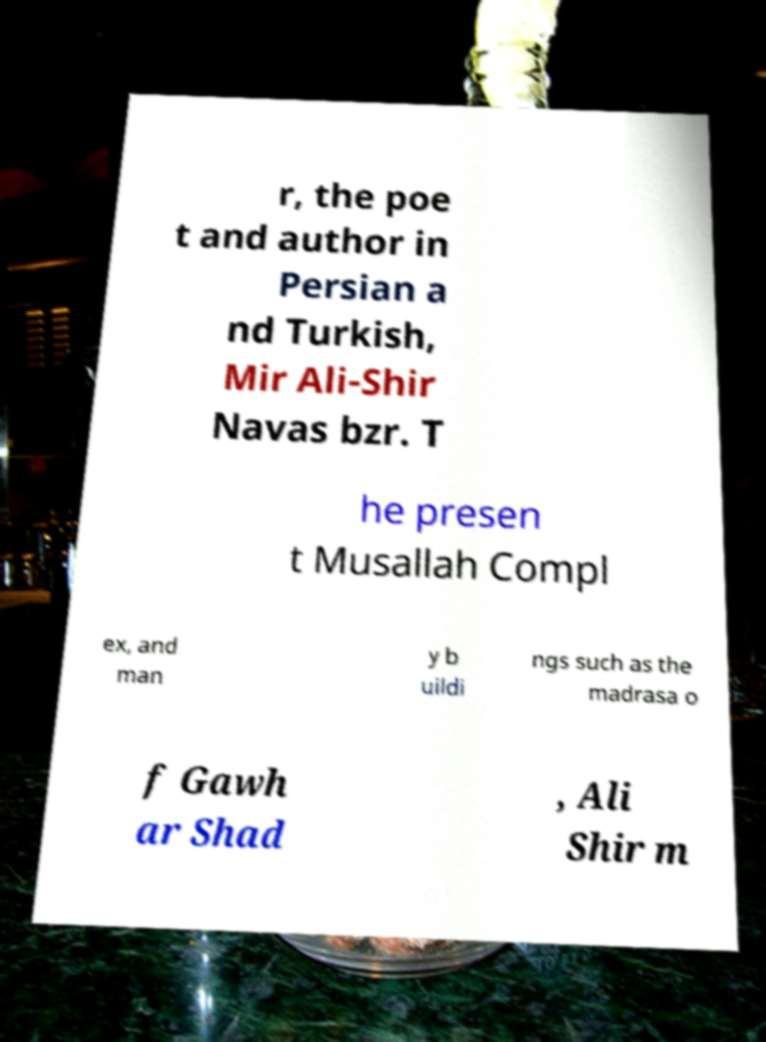Please identify and transcribe the text found in this image. r, the poe t and author in Persian a nd Turkish, Mir Ali-Shir Navas bzr. T he presen t Musallah Compl ex, and man y b uildi ngs such as the madrasa o f Gawh ar Shad , Ali Shir m 